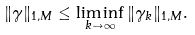<formula> <loc_0><loc_0><loc_500><loc_500>\| \gamma \| _ { 1 , M } \leq \liminf _ { k \to \infty } \| \gamma _ { k } \| _ { 1 , M } .</formula> 